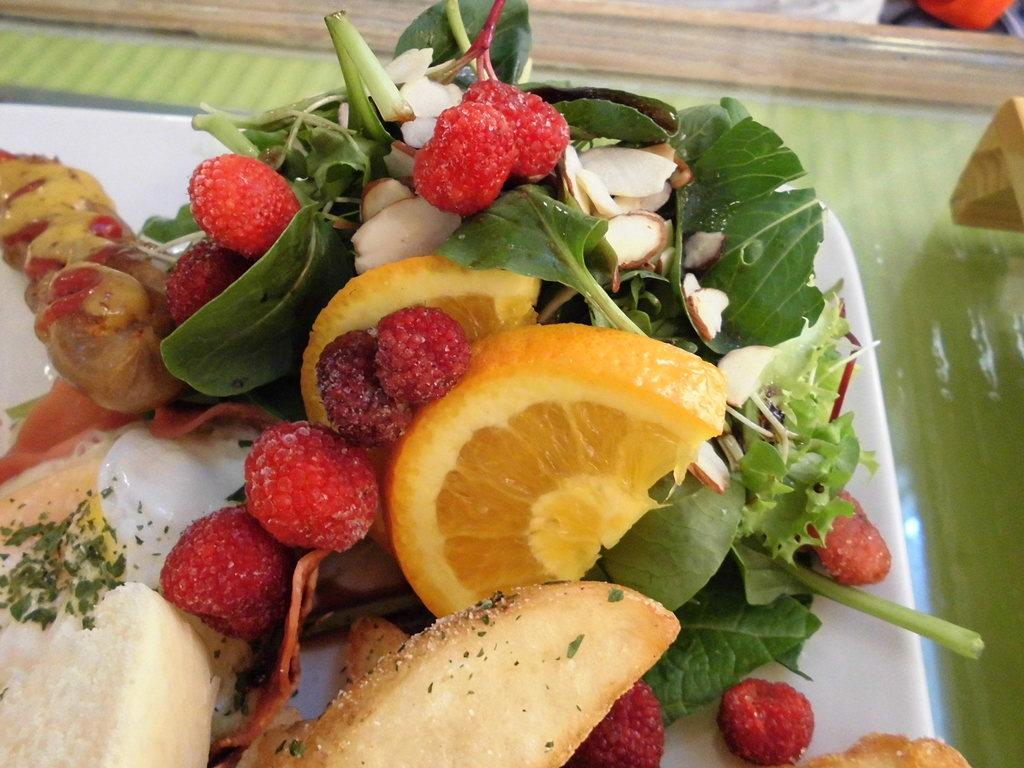What is on the table in the image? There is a tray on the table in the image. What types of food items are on the tray? The tray contains strawberries, vegetables, oranges, bread, and leaves, as well as other food items. Can you describe the red object in the top right corner of the image? Unfortunately, there is no mention of a red object in the provided facts, so we cannot describe it. What type of apparatus is being used to measure the size of the strawberries in the image? There is no apparatus present in the image for measuring the size of the strawberries. Can you describe the icicle hanging from the leaves in the image? There is no mention of an icicle in the provided facts, so we cannot describe it. 